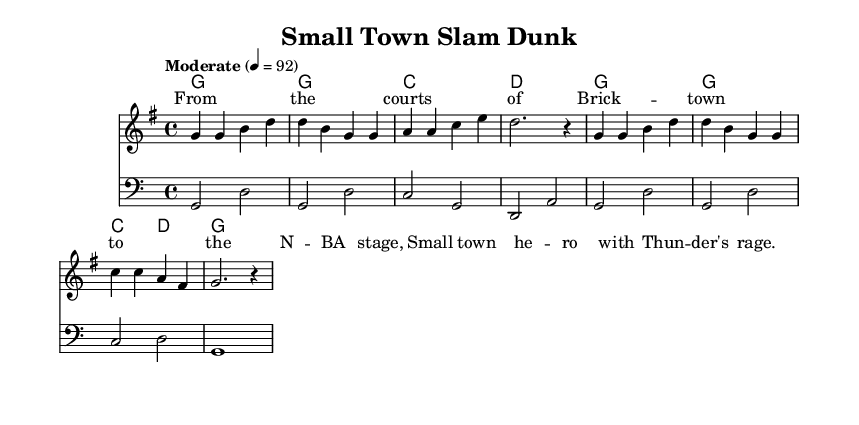What is the key signature of this music? The key signature indicated at the beginning of the music is G major, which contains one sharp (F#).
Answer: G major What is the time signature of this music? The time signature shown at the beginning is 4/4, meaning there are four beats in each measure and the quarter note gets one beat.
Answer: 4/4 What is the tempo marking of this piece? The tempo marking states "Moderate" with a metronome marking of quarter note equals 92 beats per minute, indicating the speed of the music.
Answer: Moderate 4 = 92 How many measures are in the melody section? Counting the measures in the melody, there are a total of 6 measures presented in the score.
Answer: 6 What is the main lyric theme of the verse? The lyrics reference a small-town hero rising to fame in the NBA, reflecting the country music theme of local pride and success.
Answer: Small town hero What type of harmony is used in this piece? The chord progression shows a typical country music structure, using basic triads such as G, C, and D, which are commonly found in country tunes.
Answer: Triads Which instrument is designated for the bass part? The bass part is written on the bass clef, indicating that it is intended for a lower-range instrument such as a bass guitar or double bass.
Answer: Bass 